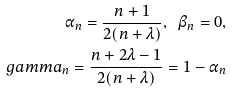Convert formula to latex. <formula><loc_0><loc_0><loc_500><loc_500>\alpha _ { n } = \frac { n + 1 } { 2 ( n + \lambda ) } , \ \beta _ { n } = 0 , \\ g a m m a _ { n } = \frac { n + 2 \lambda - 1 } { 2 ( n + \lambda ) } = 1 - \alpha _ { n }</formula> 